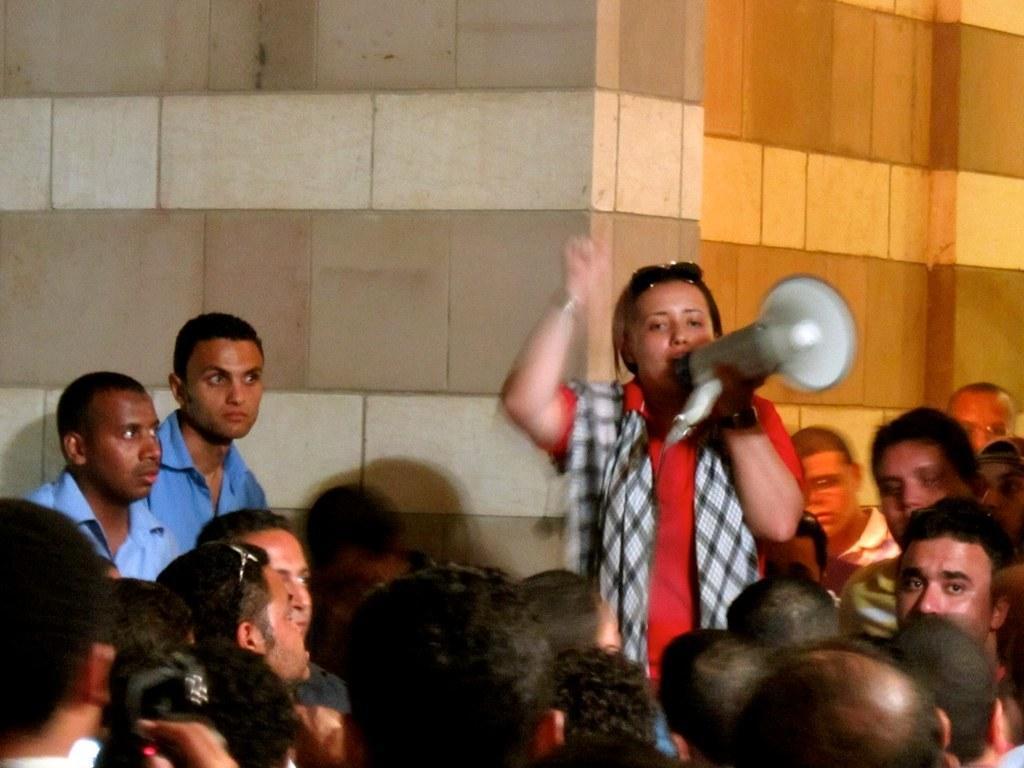Could you give a brief overview of what you see in this image? In the front of the image there are people. Among them one person is holding a speaker. In the background of the image there is wall. 